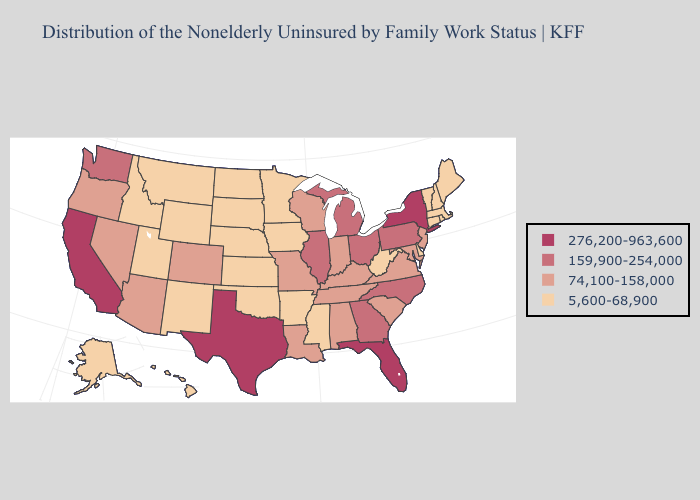Which states have the lowest value in the USA?
Write a very short answer. Alaska, Arkansas, Connecticut, Delaware, Hawaii, Idaho, Iowa, Kansas, Maine, Massachusetts, Minnesota, Mississippi, Montana, Nebraska, New Hampshire, New Mexico, North Dakota, Oklahoma, Rhode Island, South Dakota, Utah, Vermont, West Virginia, Wyoming. What is the value of Indiana?
Be succinct. 74,100-158,000. Name the states that have a value in the range 159,900-254,000?
Concise answer only. Georgia, Illinois, Michigan, North Carolina, Ohio, Pennsylvania, Washington. Does California have a lower value than Louisiana?
Write a very short answer. No. Among the states that border Minnesota , which have the lowest value?
Concise answer only. Iowa, North Dakota, South Dakota. What is the value of Virginia?
Answer briefly. 74,100-158,000. Does Virginia have a lower value than New Mexico?
Short answer required. No. Does the map have missing data?
Short answer required. No. Does Illinois have the lowest value in the MidWest?
Short answer required. No. Does Texas have the highest value in the USA?
Keep it brief. Yes. Does Nebraska have the lowest value in the MidWest?
Write a very short answer. Yes. What is the value of Alabama?
Answer briefly. 74,100-158,000. Among the states that border Florida , which have the lowest value?
Write a very short answer. Alabama. Name the states that have a value in the range 276,200-963,600?
Short answer required. California, Florida, New York, Texas. 